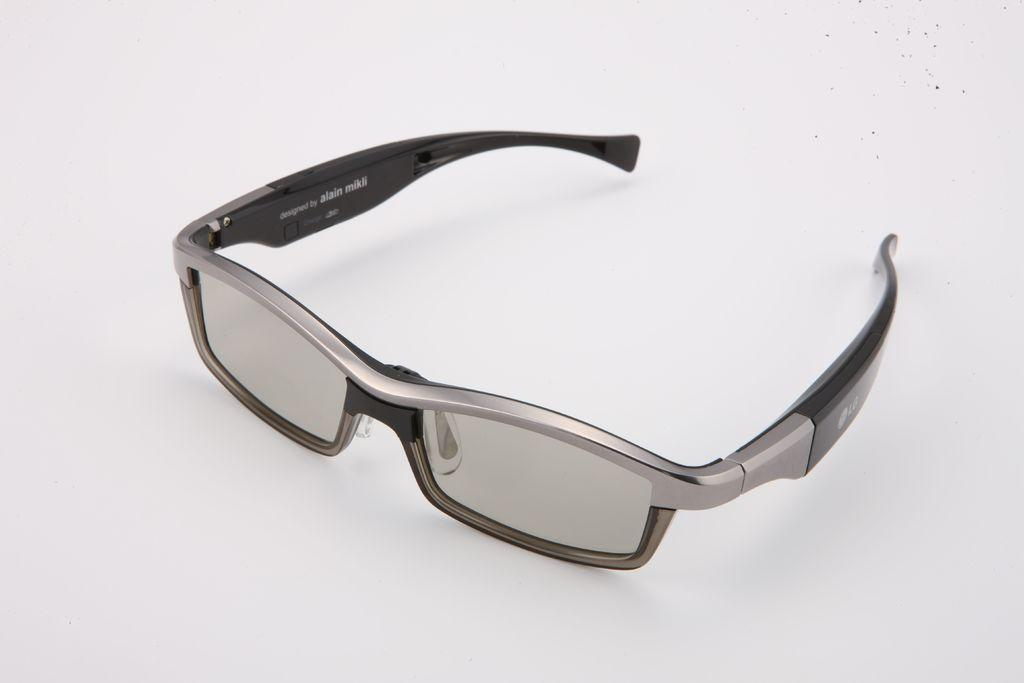What is depicted in the image? There is a picture of spectacles in the image. Where are the spectacles placed? The spectacles are on an object. What type of tin can be seen near the spectacles in the image? There is no tin present in the image. 